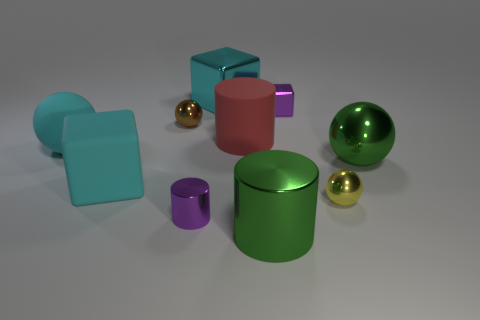What number of other objects are the same size as the yellow object?
Offer a terse response. 3. There is a metallic cube that is the same color as the tiny cylinder; what size is it?
Provide a short and direct response. Small. Are there more things that are on the left side of the cyan metal block than big green balls?
Ensure brevity in your answer.  Yes. Is there a large sphere that has the same color as the large shiny cube?
Give a very brief answer. Yes. What is the color of the metal cylinder that is the same size as the yellow object?
Your answer should be very brief. Purple. How many cyan rubber objects are in front of the large metal object that is behind the red matte cylinder?
Make the answer very short. 2. What number of things are green metallic things behind the large green metal cylinder or big cyan matte objects?
Give a very brief answer. 3. What number of small balls are made of the same material as the purple cube?
Offer a terse response. 2. There is a metallic thing that is the same color as the matte sphere; what is its shape?
Offer a terse response. Cube. Are there the same number of small brown metal balls that are in front of the small purple cylinder and small red metallic spheres?
Your response must be concise. Yes. 